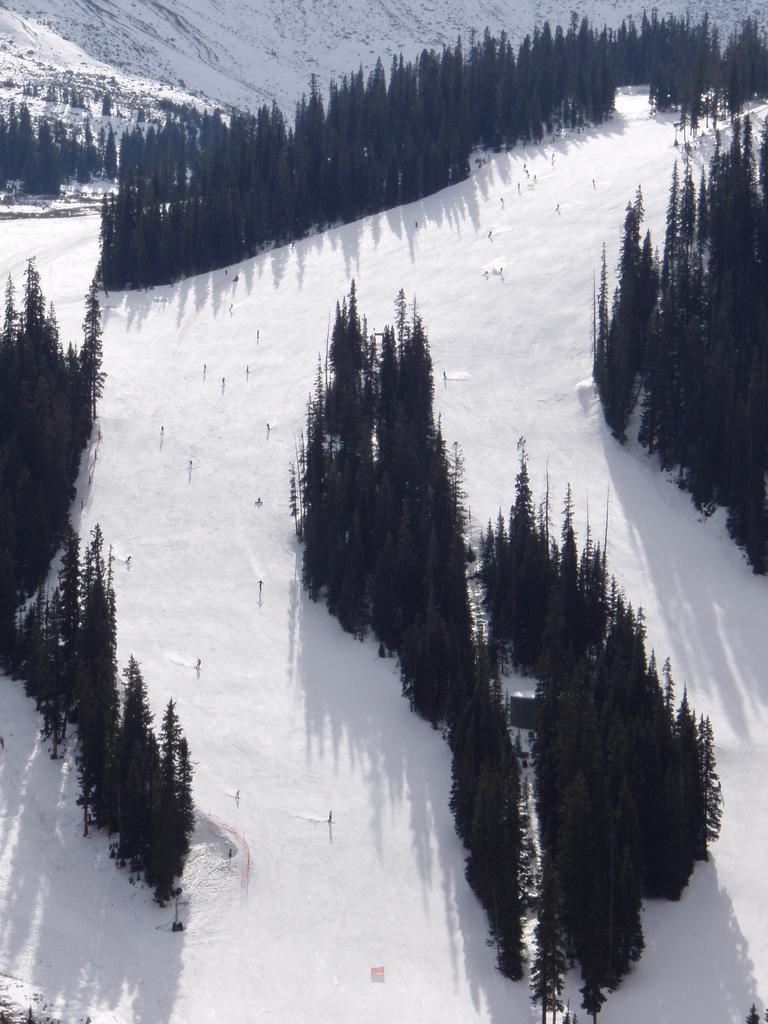Could you give a brief overview of what you see in this image? In this image we can see many trees and we can also see the snow. 